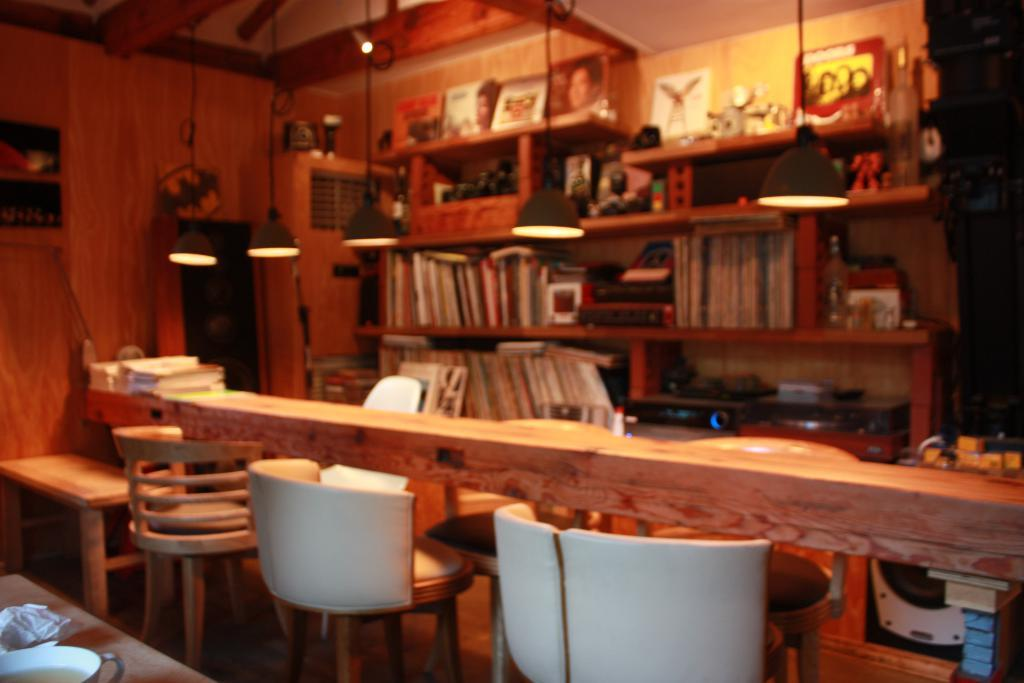What type of furniture is present in the image? There is a bookshelf, three chairs, and a table in the image. What can be seen on the walls in the image? There are lights and a wall visible in the image. Can you describe the bookshelf in the image? The bookshelf is a piece of furniture used for storing books and other items. How many chairs are there in the image? There are three chairs in the image. What grade does the cream receive in the image? There is no cream present in the image, so it is not possible to grade it. What wish is granted in the image? There is no mention of a wish or any magical elements in the image. 